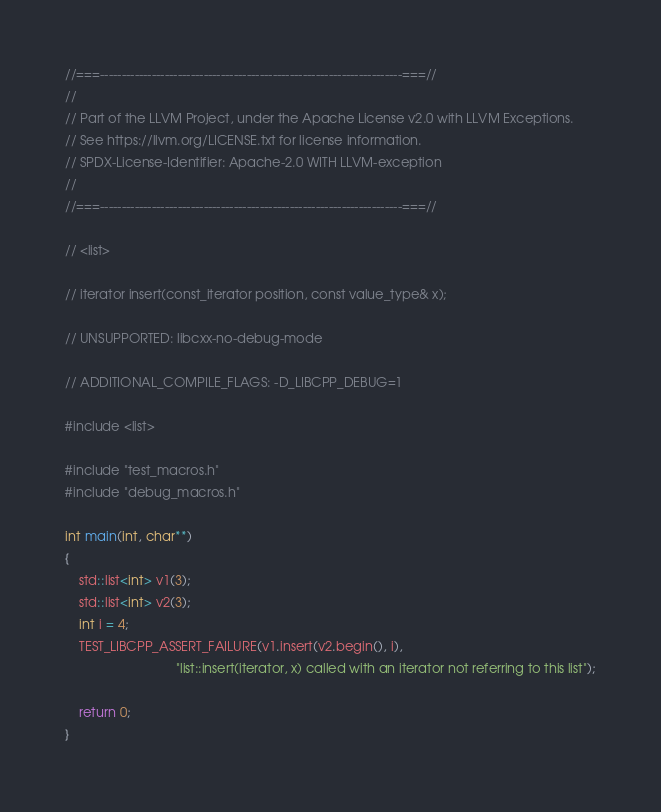<code> <loc_0><loc_0><loc_500><loc_500><_C++_>//===----------------------------------------------------------------------===//
//
// Part of the LLVM Project, under the Apache License v2.0 with LLVM Exceptions.
// See https://llvm.org/LICENSE.txt for license information.
// SPDX-License-Identifier: Apache-2.0 WITH LLVM-exception
//
//===----------------------------------------------------------------------===//

// <list>

// iterator insert(const_iterator position, const value_type& x);

// UNSUPPORTED: libcxx-no-debug-mode

// ADDITIONAL_COMPILE_FLAGS: -D_LIBCPP_DEBUG=1

#include <list>

#include "test_macros.h"
#include "debug_macros.h"

int main(int, char**)
{
    std::list<int> v1(3);
    std::list<int> v2(3);
    int i = 4;
    TEST_LIBCPP_ASSERT_FAILURE(v1.insert(v2.begin(), i),
                               "list::insert(iterator, x) called with an iterator not referring to this list");

    return 0;
}
</code> 